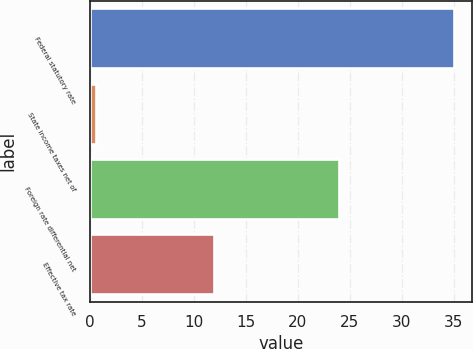<chart> <loc_0><loc_0><loc_500><loc_500><bar_chart><fcel>Federal statutory rate<fcel>State income taxes net of<fcel>Foreign rate differential net<fcel>Effective tax rate<nl><fcel>35<fcel>0.6<fcel>24<fcel>12<nl></chart> 